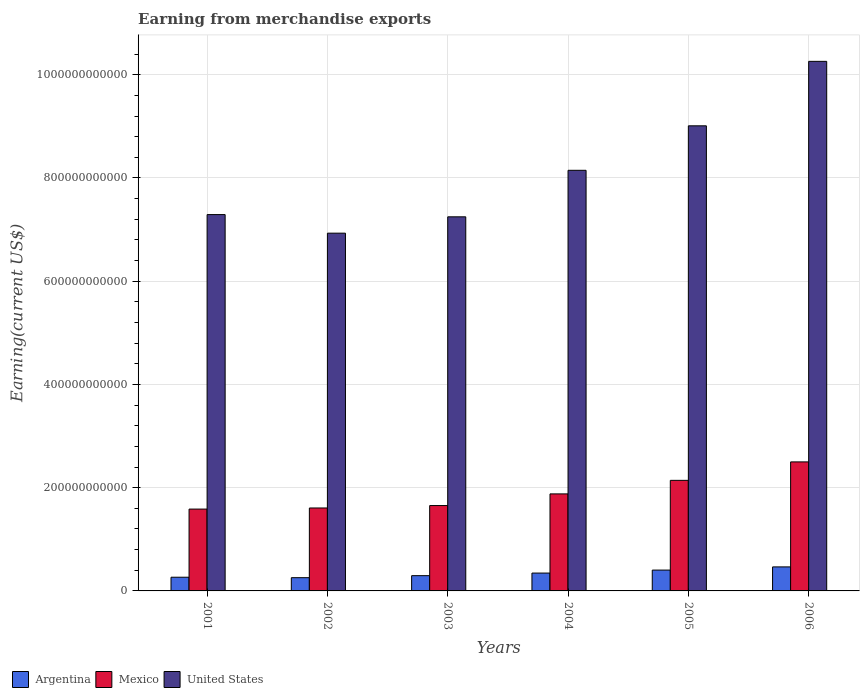Are the number of bars per tick equal to the number of legend labels?
Offer a very short reply. Yes. Are the number of bars on each tick of the X-axis equal?
Your response must be concise. Yes. How many bars are there on the 6th tick from the right?
Make the answer very short. 3. What is the label of the 1st group of bars from the left?
Give a very brief answer. 2001. What is the amount earned from merchandise exports in Argentina in 2001?
Offer a very short reply. 2.65e+1. Across all years, what is the maximum amount earned from merchandise exports in Argentina?
Give a very brief answer. 4.65e+1. Across all years, what is the minimum amount earned from merchandise exports in Mexico?
Offer a very short reply. 1.59e+11. What is the total amount earned from merchandise exports in United States in the graph?
Provide a short and direct response. 4.89e+12. What is the difference between the amount earned from merchandise exports in Argentina in 2003 and that in 2004?
Offer a very short reply. -5.01e+09. What is the difference between the amount earned from merchandise exports in Mexico in 2005 and the amount earned from merchandise exports in Argentina in 2001?
Offer a terse response. 1.88e+11. What is the average amount earned from merchandise exports in United States per year?
Your answer should be compact. 8.15e+11. In the year 2001, what is the difference between the amount earned from merchandise exports in United States and amount earned from merchandise exports in Mexico?
Your answer should be very brief. 5.71e+11. What is the ratio of the amount earned from merchandise exports in Argentina in 2003 to that in 2004?
Your answer should be compact. 0.86. What is the difference between the highest and the second highest amount earned from merchandise exports in Argentina?
Provide a succinct answer. 6.20e+09. What is the difference between the highest and the lowest amount earned from merchandise exports in Argentina?
Provide a succinct answer. 2.09e+1. Is the sum of the amount earned from merchandise exports in United States in 2003 and 2006 greater than the maximum amount earned from merchandise exports in Argentina across all years?
Provide a short and direct response. Yes. What does the 1st bar from the right in 2005 represents?
Offer a very short reply. United States. Are all the bars in the graph horizontal?
Offer a terse response. No. What is the difference between two consecutive major ticks on the Y-axis?
Make the answer very short. 2.00e+11. Does the graph contain any zero values?
Keep it short and to the point. No. Does the graph contain grids?
Keep it short and to the point. Yes. Where does the legend appear in the graph?
Offer a terse response. Bottom left. How are the legend labels stacked?
Give a very brief answer. Horizontal. What is the title of the graph?
Give a very brief answer. Earning from merchandise exports. Does "Bangladesh" appear as one of the legend labels in the graph?
Offer a terse response. No. What is the label or title of the X-axis?
Provide a succinct answer. Years. What is the label or title of the Y-axis?
Your answer should be compact. Earning(current US$). What is the Earning(current US$) in Argentina in 2001?
Keep it short and to the point. 2.65e+1. What is the Earning(current US$) in Mexico in 2001?
Your answer should be compact. 1.59e+11. What is the Earning(current US$) in United States in 2001?
Provide a succinct answer. 7.29e+11. What is the Earning(current US$) in Argentina in 2002?
Make the answer very short. 2.56e+1. What is the Earning(current US$) of Mexico in 2002?
Ensure brevity in your answer.  1.61e+11. What is the Earning(current US$) in United States in 2002?
Provide a succinct answer. 6.93e+11. What is the Earning(current US$) in Argentina in 2003?
Offer a very short reply. 2.96e+1. What is the Earning(current US$) in Mexico in 2003?
Your response must be concise. 1.65e+11. What is the Earning(current US$) in United States in 2003?
Provide a succinct answer. 7.25e+11. What is the Earning(current US$) of Argentina in 2004?
Your response must be concise. 3.46e+1. What is the Earning(current US$) of Mexico in 2004?
Provide a succinct answer. 1.88e+11. What is the Earning(current US$) of United States in 2004?
Offer a terse response. 8.15e+11. What is the Earning(current US$) of Argentina in 2005?
Provide a succinct answer. 4.04e+1. What is the Earning(current US$) of Mexico in 2005?
Provide a short and direct response. 2.14e+11. What is the Earning(current US$) in United States in 2005?
Provide a succinct answer. 9.01e+11. What is the Earning(current US$) of Argentina in 2006?
Provide a short and direct response. 4.65e+1. What is the Earning(current US$) of Mexico in 2006?
Your response must be concise. 2.50e+11. What is the Earning(current US$) in United States in 2006?
Your response must be concise. 1.03e+12. Across all years, what is the maximum Earning(current US$) of Argentina?
Provide a short and direct response. 4.65e+1. Across all years, what is the maximum Earning(current US$) in Mexico?
Provide a short and direct response. 2.50e+11. Across all years, what is the maximum Earning(current US$) of United States?
Ensure brevity in your answer.  1.03e+12. Across all years, what is the minimum Earning(current US$) of Argentina?
Provide a short and direct response. 2.56e+1. Across all years, what is the minimum Earning(current US$) in Mexico?
Provide a succinct answer. 1.59e+11. Across all years, what is the minimum Earning(current US$) in United States?
Your answer should be very brief. 6.93e+11. What is the total Earning(current US$) of Argentina in the graph?
Offer a terse response. 2.03e+11. What is the total Earning(current US$) of Mexico in the graph?
Your answer should be compact. 1.14e+12. What is the total Earning(current US$) in United States in the graph?
Provide a short and direct response. 4.89e+12. What is the difference between the Earning(current US$) in Argentina in 2001 and that in 2002?
Make the answer very short. 8.93e+08. What is the difference between the Earning(current US$) in Mexico in 2001 and that in 2002?
Provide a succinct answer. -2.14e+09. What is the difference between the Earning(current US$) of United States in 2001 and that in 2002?
Offer a terse response. 3.60e+1. What is the difference between the Earning(current US$) of Argentina in 2001 and that in 2003?
Offer a very short reply. -3.02e+09. What is the difference between the Earning(current US$) in Mexico in 2001 and that in 2003?
Your answer should be compact. -6.85e+09. What is the difference between the Earning(current US$) of United States in 2001 and that in 2003?
Give a very brief answer. 4.33e+09. What is the difference between the Earning(current US$) of Argentina in 2001 and that in 2004?
Make the answer very short. -8.03e+09. What is the difference between the Earning(current US$) of Mexico in 2001 and that in 2004?
Make the answer very short. -2.94e+1. What is the difference between the Earning(current US$) of United States in 2001 and that in 2004?
Give a very brief answer. -8.58e+1. What is the difference between the Earning(current US$) in Argentina in 2001 and that in 2005?
Keep it short and to the point. -1.38e+1. What is the difference between the Earning(current US$) in Mexico in 2001 and that in 2005?
Ensure brevity in your answer.  -5.57e+1. What is the difference between the Earning(current US$) of United States in 2001 and that in 2005?
Your response must be concise. -1.72e+11. What is the difference between the Earning(current US$) of Argentina in 2001 and that in 2006?
Give a very brief answer. -2.00e+1. What is the difference between the Earning(current US$) of Mexico in 2001 and that in 2006?
Offer a terse response. -9.14e+1. What is the difference between the Earning(current US$) in United States in 2001 and that in 2006?
Keep it short and to the point. -2.97e+11. What is the difference between the Earning(current US$) in Argentina in 2002 and that in 2003?
Your answer should be very brief. -3.92e+09. What is the difference between the Earning(current US$) of Mexico in 2002 and that in 2003?
Offer a very short reply. -4.71e+09. What is the difference between the Earning(current US$) in United States in 2002 and that in 2003?
Keep it short and to the point. -3.17e+1. What is the difference between the Earning(current US$) in Argentina in 2002 and that in 2004?
Offer a terse response. -8.93e+09. What is the difference between the Earning(current US$) in Mexico in 2002 and that in 2004?
Your answer should be very brief. -2.73e+1. What is the difference between the Earning(current US$) in United States in 2002 and that in 2004?
Your response must be concise. -1.22e+11. What is the difference between the Earning(current US$) of Argentina in 2002 and that in 2005?
Provide a succinct answer. -1.47e+1. What is the difference between the Earning(current US$) in Mexico in 2002 and that in 2005?
Your response must be concise. -5.35e+1. What is the difference between the Earning(current US$) in United States in 2002 and that in 2005?
Ensure brevity in your answer.  -2.08e+11. What is the difference between the Earning(current US$) in Argentina in 2002 and that in 2006?
Your answer should be very brief. -2.09e+1. What is the difference between the Earning(current US$) of Mexico in 2002 and that in 2006?
Give a very brief answer. -8.93e+1. What is the difference between the Earning(current US$) of United States in 2002 and that in 2006?
Ensure brevity in your answer.  -3.33e+11. What is the difference between the Earning(current US$) of Argentina in 2003 and that in 2004?
Offer a terse response. -5.01e+09. What is the difference between the Earning(current US$) of Mexico in 2003 and that in 2004?
Keep it short and to the point. -2.26e+1. What is the difference between the Earning(current US$) in United States in 2003 and that in 2004?
Offer a very short reply. -9.01e+1. What is the difference between the Earning(current US$) of Argentina in 2003 and that in 2005?
Provide a succinct answer. -1.08e+1. What is the difference between the Earning(current US$) in Mexico in 2003 and that in 2005?
Your answer should be very brief. -4.88e+1. What is the difference between the Earning(current US$) of United States in 2003 and that in 2005?
Your answer should be compact. -1.76e+11. What is the difference between the Earning(current US$) in Argentina in 2003 and that in 2006?
Ensure brevity in your answer.  -1.70e+1. What is the difference between the Earning(current US$) of Mexico in 2003 and that in 2006?
Offer a terse response. -8.46e+1. What is the difference between the Earning(current US$) of United States in 2003 and that in 2006?
Your answer should be compact. -3.01e+11. What is the difference between the Earning(current US$) in Argentina in 2004 and that in 2005?
Offer a very short reply. -5.78e+09. What is the difference between the Earning(current US$) in Mexico in 2004 and that in 2005?
Your answer should be compact. -2.62e+1. What is the difference between the Earning(current US$) in United States in 2004 and that in 2005?
Your response must be concise. -8.62e+1. What is the difference between the Earning(current US$) of Argentina in 2004 and that in 2006?
Give a very brief answer. -1.20e+1. What is the difference between the Earning(current US$) in Mexico in 2004 and that in 2006?
Offer a terse response. -6.20e+1. What is the difference between the Earning(current US$) in United States in 2004 and that in 2006?
Provide a short and direct response. -2.11e+11. What is the difference between the Earning(current US$) in Argentina in 2005 and that in 2006?
Ensure brevity in your answer.  -6.20e+09. What is the difference between the Earning(current US$) in Mexico in 2005 and that in 2006?
Your response must be concise. -3.58e+1. What is the difference between the Earning(current US$) in United States in 2005 and that in 2006?
Provide a succinct answer. -1.25e+11. What is the difference between the Earning(current US$) in Argentina in 2001 and the Earning(current US$) in Mexico in 2002?
Your response must be concise. -1.34e+11. What is the difference between the Earning(current US$) of Argentina in 2001 and the Earning(current US$) of United States in 2002?
Ensure brevity in your answer.  -6.67e+11. What is the difference between the Earning(current US$) of Mexico in 2001 and the Earning(current US$) of United States in 2002?
Your response must be concise. -5.35e+11. What is the difference between the Earning(current US$) of Argentina in 2001 and the Earning(current US$) of Mexico in 2003?
Offer a very short reply. -1.39e+11. What is the difference between the Earning(current US$) in Argentina in 2001 and the Earning(current US$) in United States in 2003?
Ensure brevity in your answer.  -6.98e+11. What is the difference between the Earning(current US$) in Mexico in 2001 and the Earning(current US$) in United States in 2003?
Your answer should be compact. -5.66e+11. What is the difference between the Earning(current US$) in Argentina in 2001 and the Earning(current US$) in Mexico in 2004?
Make the answer very short. -1.61e+11. What is the difference between the Earning(current US$) in Argentina in 2001 and the Earning(current US$) in United States in 2004?
Make the answer very short. -7.88e+11. What is the difference between the Earning(current US$) in Mexico in 2001 and the Earning(current US$) in United States in 2004?
Give a very brief answer. -6.56e+11. What is the difference between the Earning(current US$) in Argentina in 2001 and the Earning(current US$) in Mexico in 2005?
Keep it short and to the point. -1.88e+11. What is the difference between the Earning(current US$) of Argentina in 2001 and the Earning(current US$) of United States in 2005?
Make the answer very short. -8.75e+11. What is the difference between the Earning(current US$) in Mexico in 2001 and the Earning(current US$) in United States in 2005?
Offer a terse response. -7.43e+11. What is the difference between the Earning(current US$) in Argentina in 2001 and the Earning(current US$) in Mexico in 2006?
Ensure brevity in your answer.  -2.23e+11. What is the difference between the Earning(current US$) in Argentina in 2001 and the Earning(current US$) in United States in 2006?
Offer a terse response. -9.99e+11. What is the difference between the Earning(current US$) in Mexico in 2001 and the Earning(current US$) in United States in 2006?
Offer a terse response. -8.67e+11. What is the difference between the Earning(current US$) in Argentina in 2002 and the Earning(current US$) in Mexico in 2003?
Your response must be concise. -1.40e+11. What is the difference between the Earning(current US$) in Argentina in 2002 and the Earning(current US$) in United States in 2003?
Your answer should be compact. -6.99e+11. What is the difference between the Earning(current US$) in Mexico in 2002 and the Earning(current US$) in United States in 2003?
Offer a very short reply. -5.64e+11. What is the difference between the Earning(current US$) of Argentina in 2002 and the Earning(current US$) of Mexico in 2004?
Your answer should be compact. -1.62e+11. What is the difference between the Earning(current US$) of Argentina in 2002 and the Earning(current US$) of United States in 2004?
Provide a succinct answer. -7.89e+11. What is the difference between the Earning(current US$) in Mexico in 2002 and the Earning(current US$) in United States in 2004?
Provide a succinct answer. -6.54e+11. What is the difference between the Earning(current US$) in Argentina in 2002 and the Earning(current US$) in Mexico in 2005?
Provide a short and direct response. -1.89e+11. What is the difference between the Earning(current US$) of Argentina in 2002 and the Earning(current US$) of United States in 2005?
Offer a very short reply. -8.75e+11. What is the difference between the Earning(current US$) of Mexico in 2002 and the Earning(current US$) of United States in 2005?
Keep it short and to the point. -7.40e+11. What is the difference between the Earning(current US$) of Argentina in 2002 and the Earning(current US$) of Mexico in 2006?
Provide a succinct answer. -2.24e+11. What is the difference between the Earning(current US$) of Argentina in 2002 and the Earning(current US$) of United States in 2006?
Keep it short and to the point. -1.00e+12. What is the difference between the Earning(current US$) of Mexico in 2002 and the Earning(current US$) of United States in 2006?
Offer a very short reply. -8.65e+11. What is the difference between the Earning(current US$) of Argentina in 2003 and the Earning(current US$) of Mexico in 2004?
Offer a terse response. -1.58e+11. What is the difference between the Earning(current US$) of Argentina in 2003 and the Earning(current US$) of United States in 2004?
Your answer should be compact. -7.85e+11. What is the difference between the Earning(current US$) of Mexico in 2003 and the Earning(current US$) of United States in 2004?
Offer a terse response. -6.49e+11. What is the difference between the Earning(current US$) of Argentina in 2003 and the Earning(current US$) of Mexico in 2005?
Keep it short and to the point. -1.85e+11. What is the difference between the Earning(current US$) in Argentina in 2003 and the Earning(current US$) in United States in 2005?
Your answer should be compact. -8.72e+11. What is the difference between the Earning(current US$) of Mexico in 2003 and the Earning(current US$) of United States in 2005?
Your answer should be very brief. -7.36e+11. What is the difference between the Earning(current US$) of Argentina in 2003 and the Earning(current US$) of Mexico in 2006?
Your answer should be compact. -2.20e+11. What is the difference between the Earning(current US$) in Argentina in 2003 and the Earning(current US$) in United States in 2006?
Your answer should be very brief. -9.96e+11. What is the difference between the Earning(current US$) in Mexico in 2003 and the Earning(current US$) in United States in 2006?
Offer a very short reply. -8.61e+11. What is the difference between the Earning(current US$) in Argentina in 2004 and the Earning(current US$) in Mexico in 2005?
Provide a short and direct response. -1.80e+11. What is the difference between the Earning(current US$) of Argentina in 2004 and the Earning(current US$) of United States in 2005?
Make the answer very short. -8.67e+11. What is the difference between the Earning(current US$) in Mexico in 2004 and the Earning(current US$) in United States in 2005?
Provide a short and direct response. -7.13e+11. What is the difference between the Earning(current US$) of Argentina in 2004 and the Earning(current US$) of Mexico in 2006?
Provide a short and direct response. -2.15e+11. What is the difference between the Earning(current US$) in Argentina in 2004 and the Earning(current US$) in United States in 2006?
Your answer should be very brief. -9.91e+11. What is the difference between the Earning(current US$) of Mexico in 2004 and the Earning(current US$) of United States in 2006?
Offer a very short reply. -8.38e+11. What is the difference between the Earning(current US$) in Argentina in 2005 and the Earning(current US$) in Mexico in 2006?
Keep it short and to the point. -2.10e+11. What is the difference between the Earning(current US$) of Argentina in 2005 and the Earning(current US$) of United States in 2006?
Provide a succinct answer. -9.86e+11. What is the difference between the Earning(current US$) in Mexico in 2005 and the Earning(current US$) in United States in 2006?
Offer a very short reply. -8.12e+11. What is the average Earning(current US$) of Argentina per year?
Ensure brevity in your answer.  3.39e+1. What is the average Earning(current US$) of Mexico per year?
Your response must be concise. 1.89e+11. What is the average Earning(current US$) in United States per year?
Your response must be concise. 8.15e+11. In the year 2001, what is the difference between the Earning(current US$) of Argentina and Earning(current US$) of Mexico?
Provide a succinct answer. -1.32e+11. In the year 2001, what is the difference between the Earning(current US$) in Argentina and Earning(current US$) in United States?
Your answer should be very brief. -7.03e+11. In the year 2001, what is the difference between the Earning(current US$) in Mexico and Earning(current US$) in United States?
Your response must be concise. -5.71e+11. In the year 2002, what is the difference between the Earning(current US$) in Argentina and Earning(current US$) in Mexico?
Offer a very short reply. -1.35e+11. In the year 2002, what is the difference between the Earning(current US$) of Argentina and Earning(current US$) of United States?
Provide a short and direct response. -6.67e+11. In the year 2002, what is the difference between the Earning(current US$) in Mexico and Earning(current US$) in United States?
Your answer should be very brief. -5.32e+11. In the year 2003, what is the difference between the Earning(current US$) of Argentina and Earning(current US$) of Mexico?
Offer a very short reply. -1.36e+11. In the year 2003, what is the difference between the Earning(current US$) in Argentina and Earning(current US$) in United States?
Your answer should be very brief. -6.95e+11. In the year 2003, what is the difference between the Earning(current US$) of Mexico and Earning(current US$) of United States?
Make the answer very short. -5.59e+11. In the year 2004, what is the difference between the Earning(current US$) in Argentina and Earning(current US$) in Mexico?
Your response must be concise. -1.53e+11. In the year 2004, what is the difference between the Earning(current US$) in Argentina and Earning(current US$) in United States?
Provide a succinct answer. -7.80e+11. In the year 2004, what is the difference between the Earning(current US$) in Mexico and Earning(current US$) in United States?
Your answer should be very brief. -6.27e+11. In the year 2005, what is the difference between the Earning(current US$) in Argentina and Earning(current US$) in Mexico?
Your response must be concise. -1.74e+11. In the year 2005, what is the difference between the Earning(current US$) of Argentina and Earning(current US$) of United States?
Make the answer very short. -8.61e+11. In the year 2005, what is the difference between the Earning(current US$) of Mexico and Earning(current US$) of United States?
Your answer should be very brief. -6.87e+11. In the year 2006, what is the difference between the Earning(current US$) in Argentina and Earning(current US$) in Mexico?
Keep it short and to the point. -2.03e+11. In the year 2006, what is the difference between the Earning(current US$) of Argentina and Earning(current US$) of United States?
Your answer should be compact. -9.79e+11. In the year 2006, what is the difference between the Earning(current US$) of Mexico and Earning(current US$) of United States?
Give a very brief answer. -7.76e+11. What is the ratio of the Earning(current US$) of Argentina in 2001 to that in 2002?
Make the answer very short. 1.03. What is the ratio of the Earning(current US$) in Mexico in 2001 to that in 2002?
Give a very brief answer. 0.99. What is the ratio of the Earning(current US$) in United States in 2001 to that in 2002?
Your response must be concise. 1.05. What is the ratio of the Earning(current US$) in Argentina in 2001 to that in 2003?
Your answer should be very brief. 0.9. What is the ratio of the Earning(current US$) in Mexico in 2001 to that in 2003?
Make the answer very short. 0.96. What is the ratio of the Earning(current US$) in United States in 2001 to that in 2003?
Provide a succinct answer. 1.01. What is the ratio of the Earning(current US$) in Argentina in 2001 to that in 2004?
Ensure brevity in your answer.  0.77. What is the ratio of the Earning(current US$) of Mexico in 2001 to that in 2004?
Give a very brief answer. 0.84. What is the ratio of the Earning(current US$) of United States in 2001 to that in 2004?
Ensure brevity in your answer.  0.89. What is the ratio of the Earning(current US$) in Argentina in 2001 to that in 2005?
Your answer should be very brief. 0.66. What is the ratio of the Earning(current US$) of Mexico in 2001 to that in 2005?
Your answer should be very brief. 0.74. What is the ratio of the Earning(current US$) in United States in 2001 to that in 2005?
Offer a terse response. 0.81. What is the ratio of the Earning(current US$) in Argentina in 2001 to that in 2006?
Give a very brief answer. 0.57. What is the ratio of the Earning(current US$) of Mexico in 2001 to that in 2006?
Your answer should be compact. 0.63. What is the ratio of the Earning(current US$) of United States in 2001 to that in 2006?
Give a very brief answer. 0.71. What is the ratio of the Earning(current US$) of Argentina in 2002 to that in 2003?
Provide a succinct answer. 0.87. What is the ratio of the Earning(current US$) in Mexico in 2002 to that in 2003?
Keep it short and to the point. 0.97. What is the ratio of the Earning(current US$) of United States in 2002 to that in 2003?
Your answer should be compact. 0.96. What is the ratio of the Earning(current US$) in Argentina in 2002 to that in 2004?
Offer a terse response. 0.74. What is the ratio of the Earning(current US$) in Mexico in 2002 to that in 2004?
Provide a succinct answer. 0.85. What is the ratio of the Earning(current US$) of United States in 2002 to that in 2004?
Provide a succinct answer. 0.85. What is the ratio of the Earning(current US$) in Argentina in 2002 to that in 2005?
Your response must be concise. 0.64. What is the ratio of the Earning(current US$) in Mexico in 2002 to that in 2005?
Your answer should be compact. 0.75. What is the ratio of the Earning(current US$) in United States in 2002 to that in 2005?
Provide a short and direct response. 0.77. What is the ratio of the Earning(current US$) of Argentina in 2002 to that in 2006?
Make the answer very short. 0.55. What is the ratio of the Earning(current US$) of Mexico in 2002 to that in 2006?
Offer a very short reply. 0.64. What is the ratio of the Earning(current US$) of United States in 2002 to that in 2006?
Give a very brief answer. 0.68. What is the ratio of the Earning(current US$) in Argentina in 2003 to that in 2004?
Offer a terse response. 0.86. What is the ratio of the Earning(current US$) of Mexico in 2003 to that in 2004?
Offer a terse response. 0.88. What is the ratio of the Earning(current US$) in United States in 2003 to that in 2004?
Offer a terse response. 0.89. What is the ratio of the Earning(current US$) in Argentina in 2003 to that in 2005?
Make the answer very short. 0.73. What is the ratio of the Earning(current US$) of Mexico in 2003 to that in 2005?
Keep it short and to the point. 0.77. What is the ratio of the Earning(current US$) in United States in 2003 to that in 2005?
Provide a succinct answer. 0.8. What is the ratio of the Earning(current US$) of Argentina in 2003 to that in 2006?
Your answer should be compact. 0.64. What is the ratio of the Earning(current US$) of Mexico in 2003 to that in 2006?
Offer a terse response. 0.66. What is the ratio of the Earning(current US$) of United States in 2003 to that in 2006?
Make the answer very short. 0.71. What is the ratio of the Earning(current US$) of Argentina in 2004 to that in 2005?
Your answer should be compact. 0.86. What is the ratio of the Earning(current US$) in Mexico in 2004 to that in 2005?
Your answer should be very brief. 0.88. What is the ratio of the Earning(current US$) of United States in 2004 to that in 2005?
Ensure brevity in your answer.  0.9. What is the ratio of the Earning(current US$) of Argentina in 2004 to that in 2006?
Give a very brief answer. 0.74. What is the ratio of the Earning(current US$) of Mexico in 2004 to that in 2006?
Your answer should be very brief. 0.75. What is the ratio of the Earning(current US$) in United States in 2004 to that in 2006?
Give a very brief answer. 0.79. What is the ratio of the Earning(current US$) in Argentina in 2005 to that in 2006?
Ensure brevity in your answer.  0.87. What is the ratio of the Earning(current US$) of Mexico in 2005 to that in 2006?
Your answer should be compact. 0.86. What is the ratio of the Earning(current US$) of United States in 2005 to that in 2006?
Provide a succinct answer. 0.88. What is the difference between the highest and the second highest Earning(current US$) in Argentina?
Offer a very short reply. 6.20e+09. What is the difference between the highest and the second highest Earning(current US$) of Mexico?
Offer a terse response. 3.58e+1. What is the difference between the highest and the second highest Earning(current US$) in United States?
Offer a very short reply. 1.25e+11. What is the difference between the highest and the lowest Earning(current US$) in Argentina?
Your answer should be compact. 2.09e+1. What is the difference between the highest and the lowest Earning(current US$) in Mexico?
Your response must be concise. 9.14e+1. What is the difference between the highest and the lowest Earning(current US$) of United States?
Provide a short and direct response. 3.33e+11. 